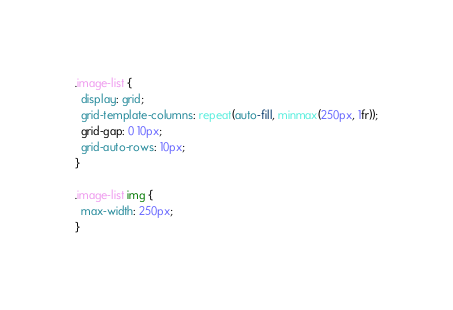Convert code to text. <code><loc_0><loc_0><loc_500><loc_500><_CSS_>.image-list {
  display: grid;
  grid-template-columns: repeat(auto-fill, minmax(250px, 1fr));
  grid-gap: 0 10px;
  grid-auto-rows: 10px;
}

.image-list img {
  max-width: 250px;
}
</code> 